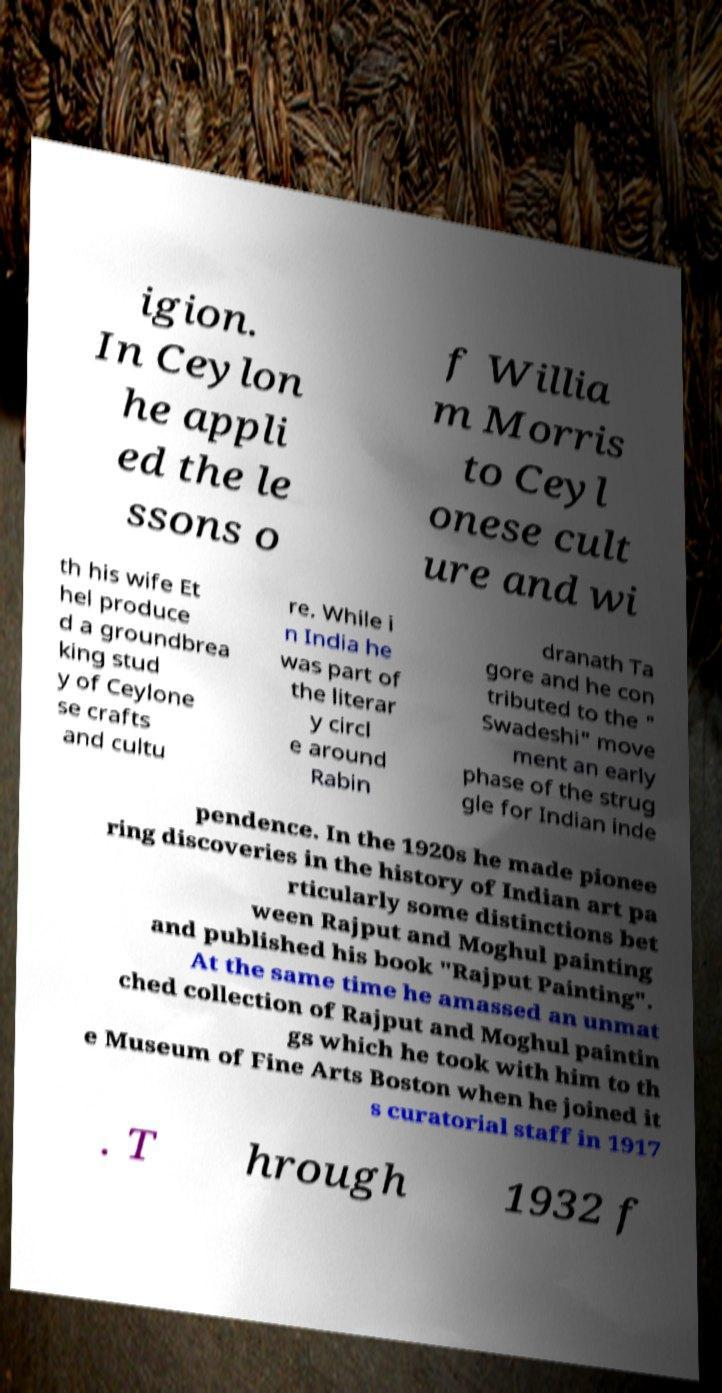I need the written content from this picture converted into text. Can you do that? igion. In Ceylon he appli ed the le ssons o f Willia m Morris to Ceyl onese cult ure and wi th his wife Et hel produce d a groundbrea king stud y of Ceylone se crafts and cultu re. While i n India he was part of the literar y circl e around Rabin dranath Ta gore and he con tributed to the " Swadeshi" move ment an early phase of the strug gle for Indian inde pendence. In the 1920s he made pionee ring discoveries in the history of Indian art pa rticularly some distinctions bet ween Rajput and Moghul painting and published his book "Rajput Painting". At the same time he amassed an unmat ched collection of Rajput and Moghul paintin gs which he took with him to th e Museum of Fine Arts Boston when he joined it s curatorial staff in 1917 . T hrough 1932 f 